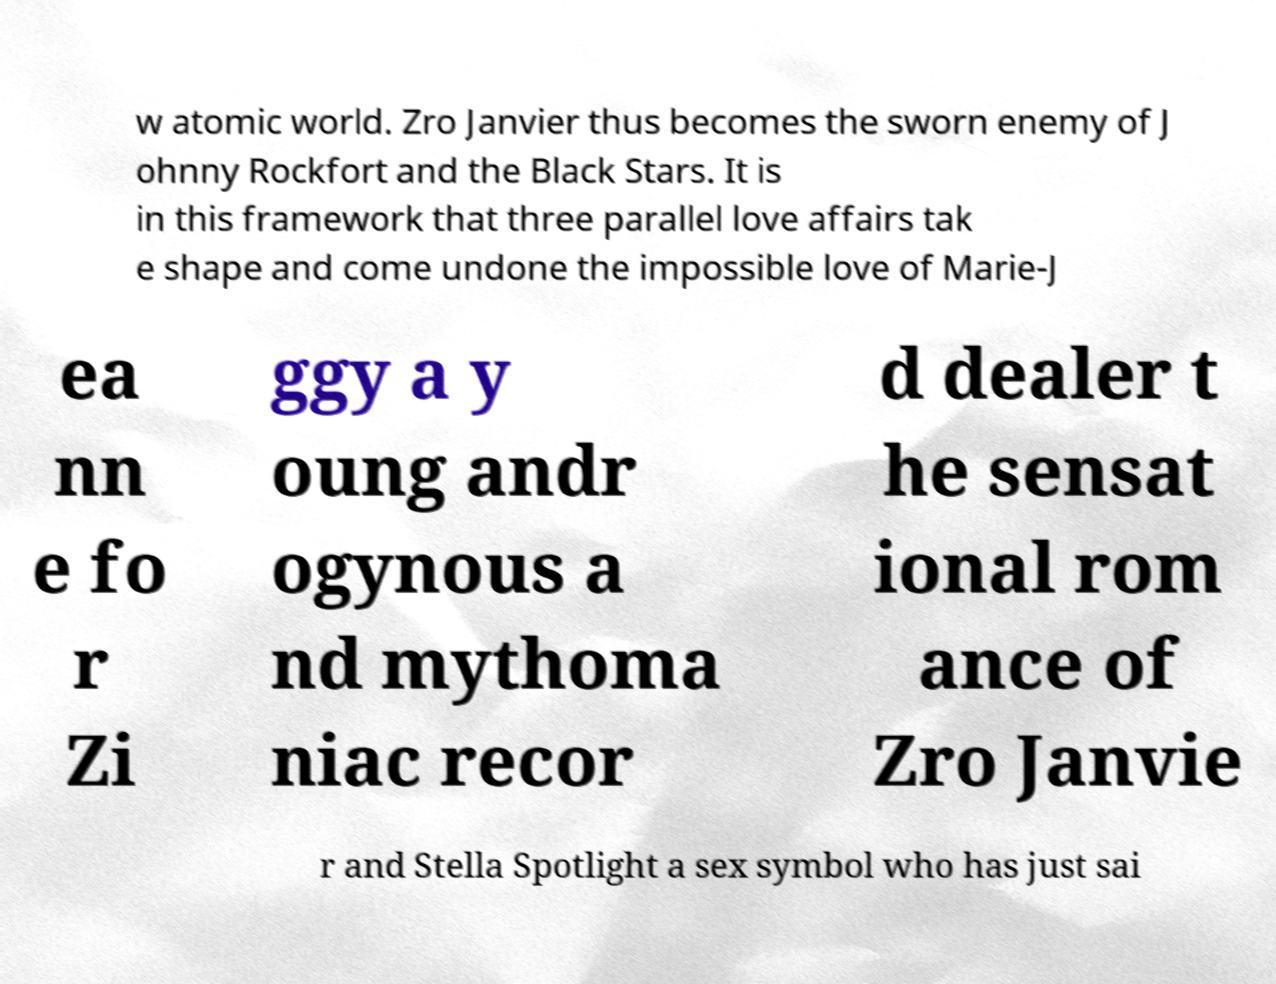Please identify and transcribe the text found in this image. w atomic world. Zro Janvier thus becomes the sworn enemy of J ohnny Rockfort and the Black Stars. It is in this framework that three parallel love affairs tak e shape and come undone the impossible love of Marie-J ea nn e fo r Zi ggy a y oung andr ogynous a nd mythoma niac recor d dealer t he sensat ional rom ance of Zro Janvie r and Stella Spotlight a sex symbol who has just sai 